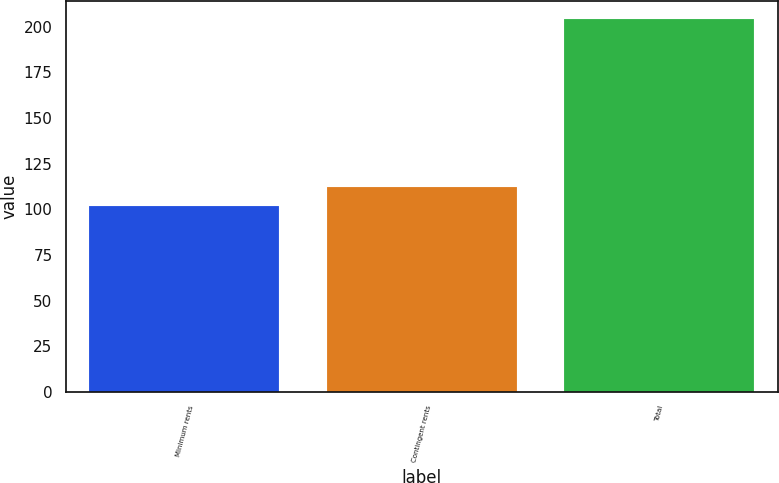Convert chart to OTSL. <chart><loc_0><loc_0><loc_500><loc_500><bar_chart><fcel>Minimum rents<fcel>Contingent rents<fcel>Total<nl><fcel>102<fcel>112.2<fcel>204<nl></chart> 